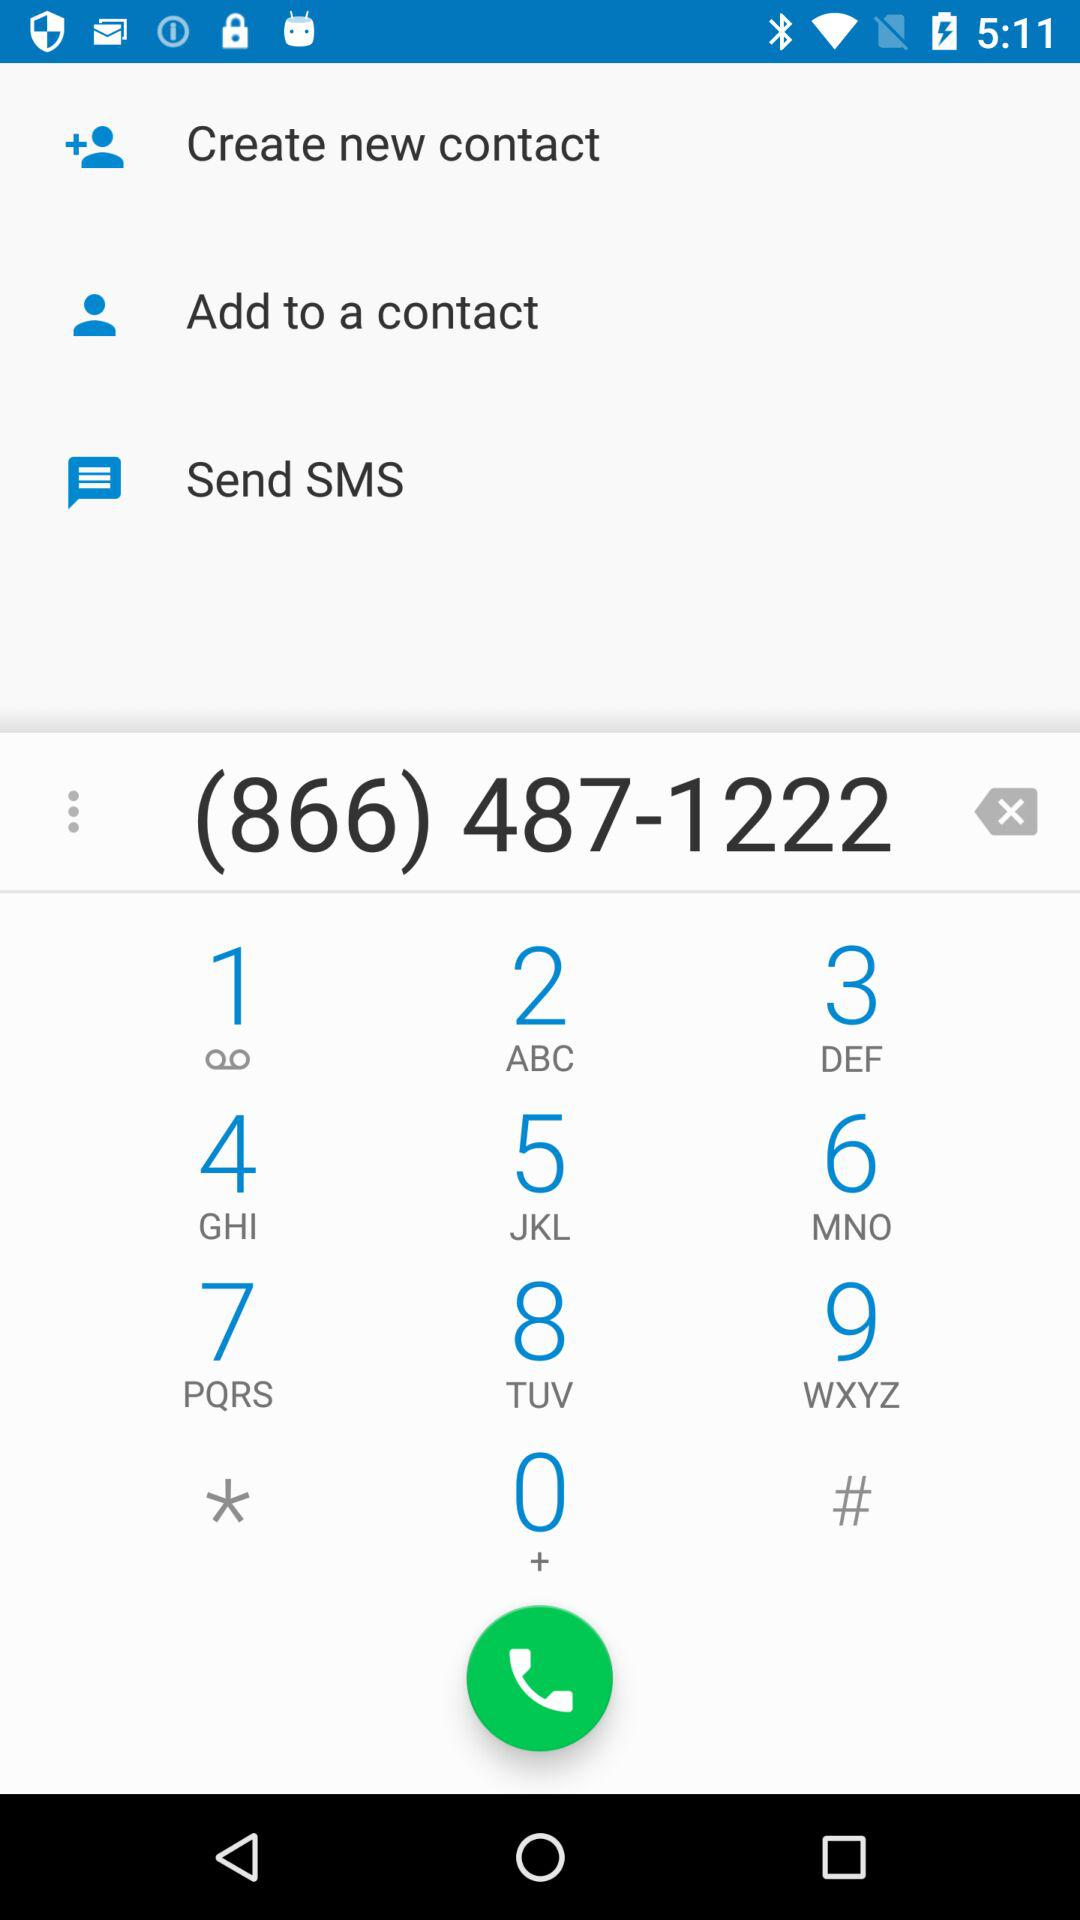What is the phone number? The phone number is (866) 487-1222. 